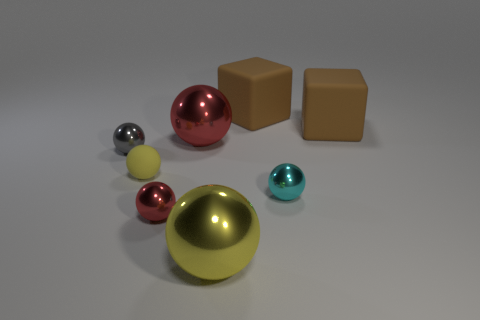Subtract all cyan spheres. How many spheres are left? 5 Subtract all small yellow balls. How many balls are left? 5 Subtract all gray balls. Subtract all yellow cylinders. How many balls are left? 5 Add 1 big cubes. How many objects exist? 9 Subtract all blocks. How many objects are left? 6 Add 1 big shiny objects. How many big shiny objects are left? 3 Add 7 yellow objects. How many yellow objects exist? 9 Subtract 0 gray cylinders. How many objects are left? 8 Subtract all large red things. Subtract all cyan objects. How many objects are left? 6 